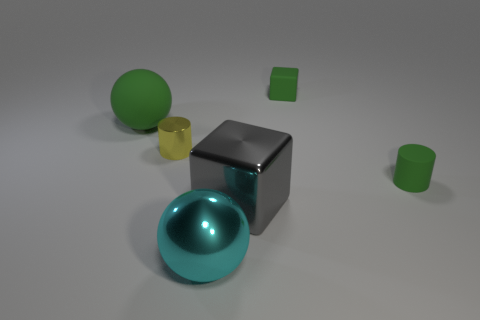Is there a big red object? Actually, there are no red objects in the image; the prominent colors are green, blue, yellow, and gray. 